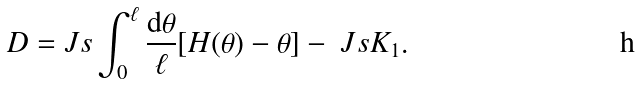Convert formula to latex. <formula><loc_0><loc_0><loc_500><loc_500>D = & \ J s \int _ { 0 } ^ { \ell } \frac { { \mathrm d } \theta } { \ell } [ H ( \theta ) - \theta ] - \ J s K _ { 1 } .</formula> 